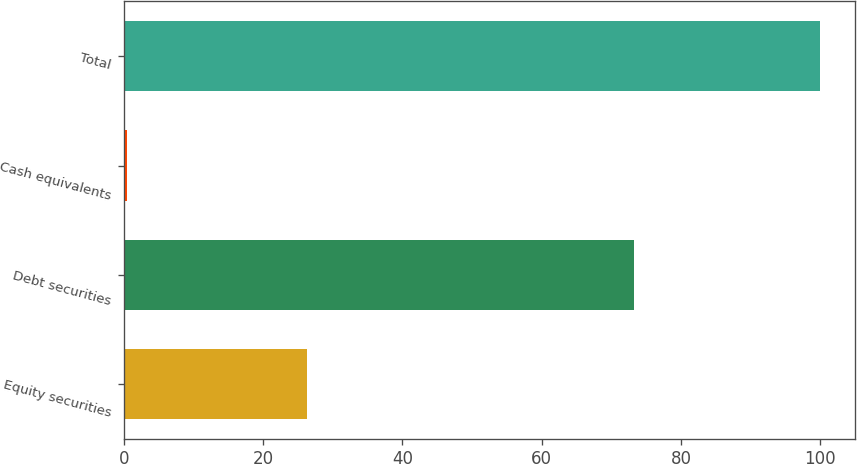Convert chart. <chart><loc_0><loc_0><loc_500><loc_500><bar_chart><fcel>Equity securities<fcel>Debt securities<fcel>Cash equivalents<fcel>Total<nl><fcel>26.3<fcel>73.3<fcel>0.4<fcel>100<nl></chart> 